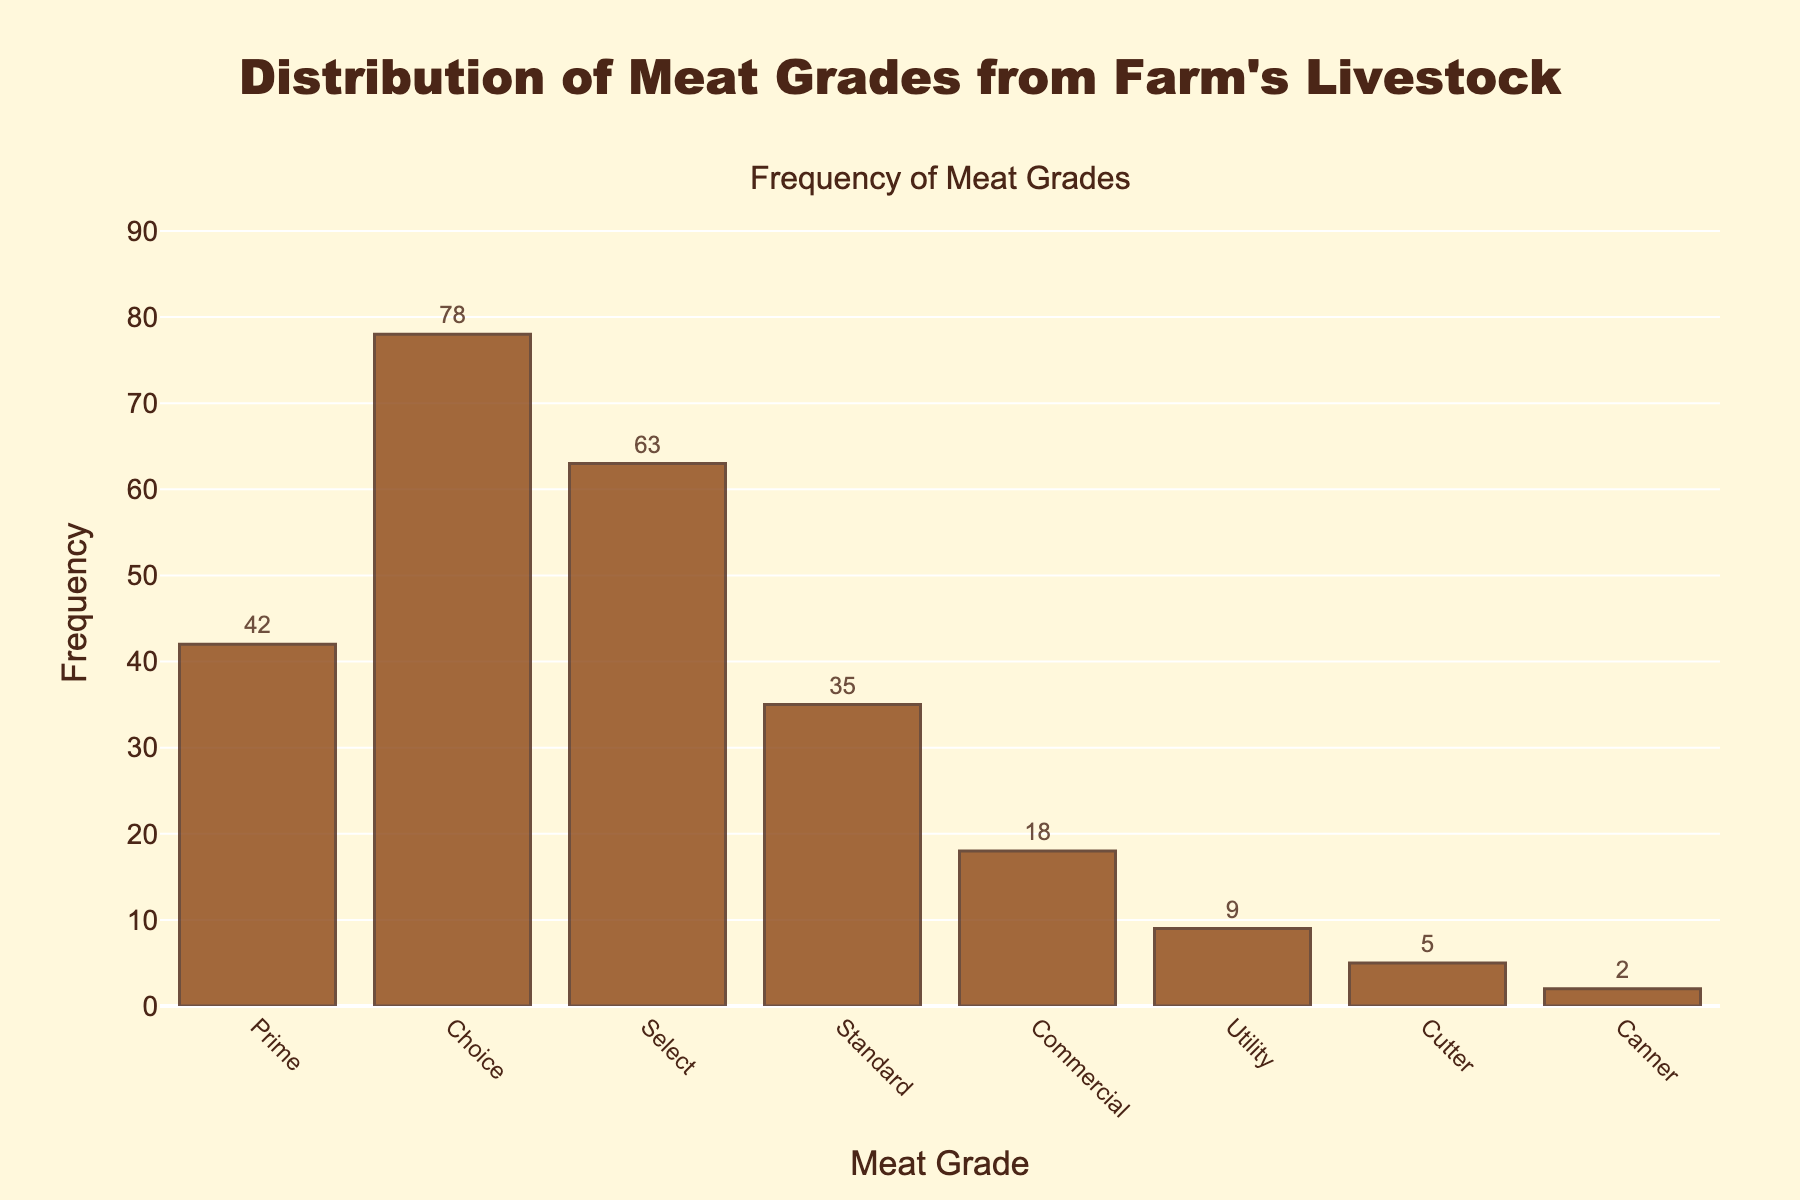What is the title of the figure? The title of the figure is displayed prominently at the top.
Answer: Distribution of Meat Grades from Farm's Livestock What is the most frequent grade of meat? The bar with the highest value represents the most frequent grade of meat.
Answer: Choice How many grades of meat are represented in the figure? Count the number of distinct bars shown in the histogram.
Answer: 8 Which grade has the lowest frequency and what is it? Identify the shortest bar and read its label and value.
Answer: Canner, 2 What is the total frequency of grades Prime and Choice combined? Add the frequencies of Prime (42) and Choice (78).
Answer: 120 How much more frequent is the Select grade than the Standard grade? Subtract the frequency of Standard (35) from Select (63).
Answer: 28 Which grades have a frequency of more than 50? Identify and list the grades with bars exceeding the 50 mark on the y-axis.
Answer: Prime, Choice, Select What is the average frequency of the grades? Add all frequencies and divide by the number of grades: (42+78+63+35+18+9+5+2) / 8 = 31.5
Answer: 31.5 Is there a grade with a frequency between 30 and 40? Check if any bar's frequency falls between 30 and 40.
Answer: Yes, Standard (35) Rank the grades from highest to lowest frequency. Arrange the grades in descending order of their frequencies.
Answer: Choice, Select, Prime, Standard, Commercial, Utility, Cutter, Canner 